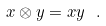<formula> <loc_0><loc_0><loc_500><loc_500>x \otimes y = x y \ .</formula> 